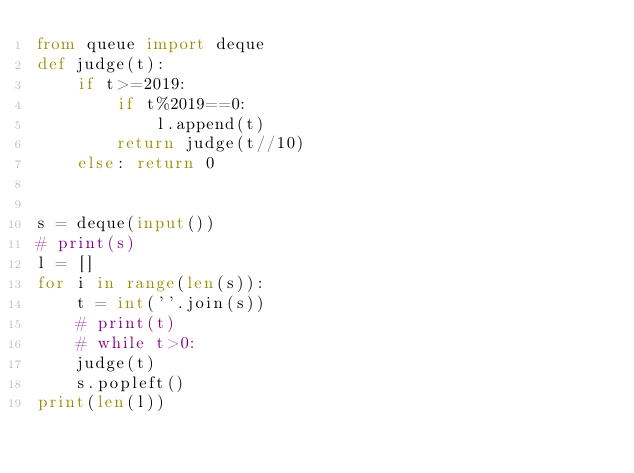<code> <loc_0><loc_0><loc_500><loc_500><_Python_>from queue import deque
def judge(t):
    if t>=2019:
        if t%2019==0:
            l.append(t)
        return judge(t//10)
    else: return 0
    

s = deque(input())
# print(s)
l = []
for i in range(len(s)):
    t = int(''.join(s))
    # print(t)
    # while t>0:
    judge(t)
    s.popleft()
print(len(l))</code> 